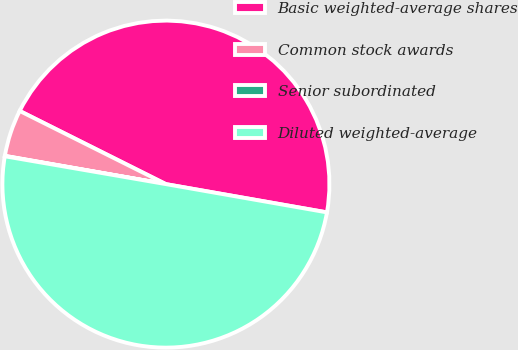<chart> <loc_0><loc_0><loc_500><loc_500><pie_chart><fcel>Basic weighted-average shares<fcel>Common stock awards<fcel>Senior subordinated<fcel>Diluted weighted-average<nl><fcel>45.38%<fcel>4.62%<fcel>0.04%<fcel>49.96%<nl></chart> 